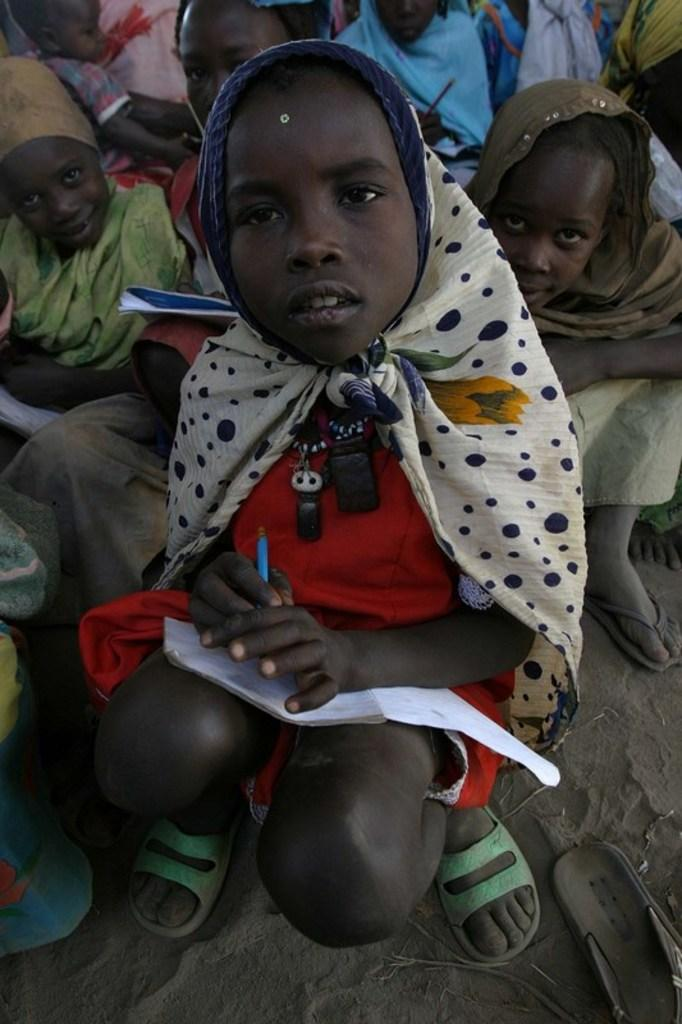How many children are present in the image? There are many children in the image. Can you describe the child in the front of the image? The child in the front of the image is wearing a scarf and holding a book. What is the texture or material at the bottom of the image? There is sand at the bottom of the image. What type of humor can be seen in the image? There is no humor present in the image; it features children and sand. Can you describe the cushion used for sitting in the image? There is no cushion present in the image. 